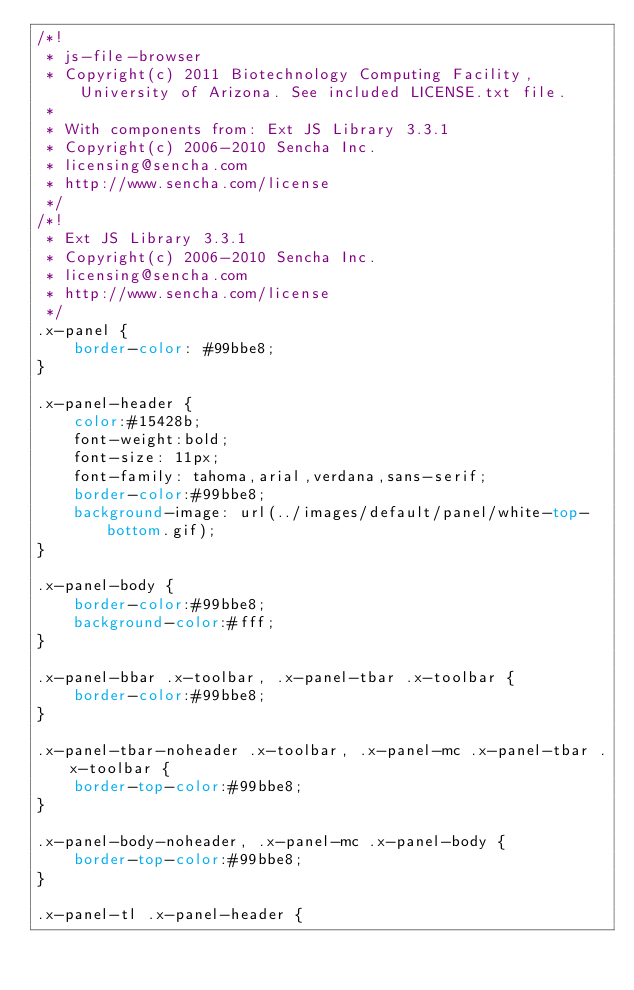Convert code to text. <code><loc_0><loc_0><loc_500><loc_500><_CSS_>/*!
 * js-file-browser
 * Copyright(c) 2011 Biotechnology Computing Facility, University of Arizona. See included LICENSE.txt file.
 * 
 * With components from: Ext JS Library 3.3.1
 * Copyright(c) 2006-2010 Sencha Inc.
 * licensing@sencha.com
 * http://www.sencha.com/license
 */
/*!
 * Ext JS Library 3.3.1
 * Copyright(c) 2006-2010 Sencha Inc.
 * licensing@sencha.com
 * http://www.sencha.com/license
 */
.x-panel {
    border-color: #99bbe8;
}

.x-panel-header {
    color:#15428b;
	font-weight:bold; 
    font-size: 11px;
    font-family: tahoma,arial,verdana,sans-serif;
    border-color:#99bbe8;
    background-image: url(../images/default/panel/white-top-bottom.gif);
}

.x-panel-body {
    border-color:#99bbe8;
    background-color:#fff;
}

.x-panel-bbar .x-toolbar, .x-panel-tbar .x-toolbar {
    border-color:#99bbe8;
}

.x-panel-tbar-noheader .x-toolbar, .x-panel-mc .x-panel-tbar .x-toolbar {
    border-top-color:#99bbe8;
}

.x-panel-body-noheader, .x-panel-mc .x-panel-body {
    border-top-color:#99bbe8;
}

.x-panel-tl .x-panel-header {</code> 